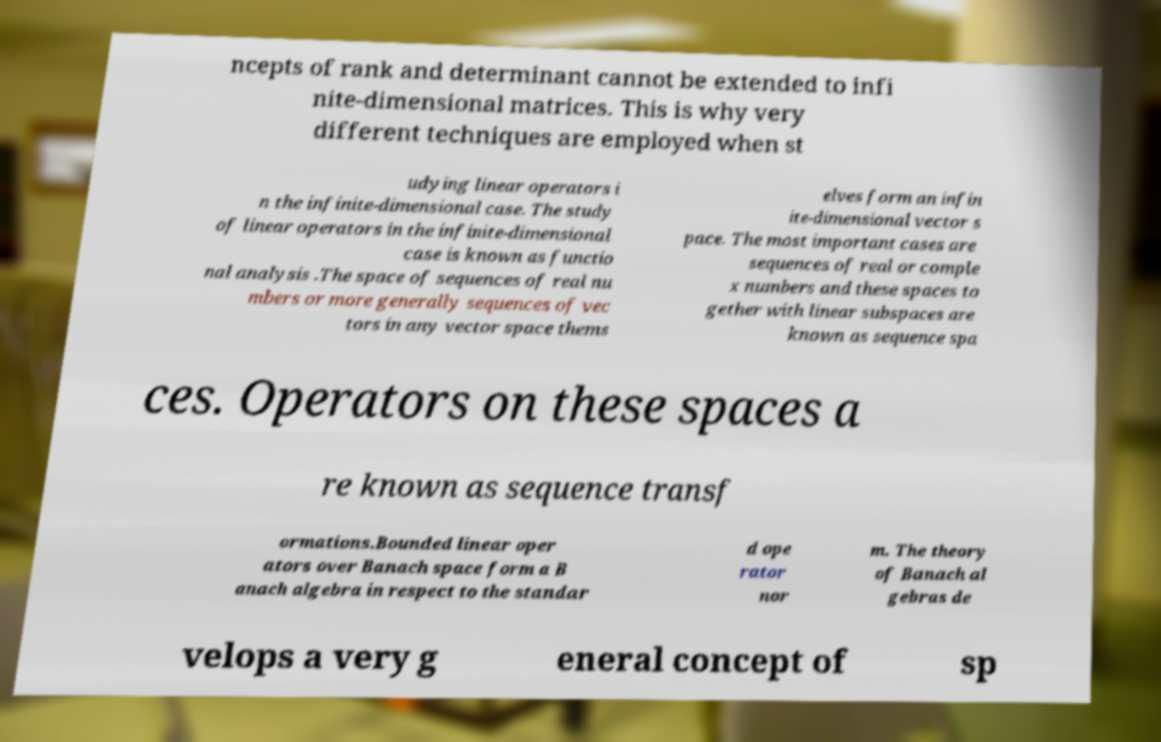Please read and relay the text visible in this image. What does it say? ncepts of rank and determinant cannot be extended to infi nite-dimensional matrices. This is why very different techniques are employed when st udying linear operators i n the infinite-dimensional case. The study of linear operators in the infinite-dimensional case is known as functio nal analysis .The space of sequences of real nu mbers or more generally sequences of vec tors in any vector space thems elves form an infin ite-dimensional vector s pace. The most important cases are sequences of real or comple x numbers and these spaces to gether with linear subspaces are known as sequence spa ces. Operators on these spaces a re known as sequence transf ormations.Bounded linear oper ators over Banach space form a B anach algebra in respect to the standar d ope rator nor m. The theory of Banach al gebras de velops a very g eneral concept of sp 